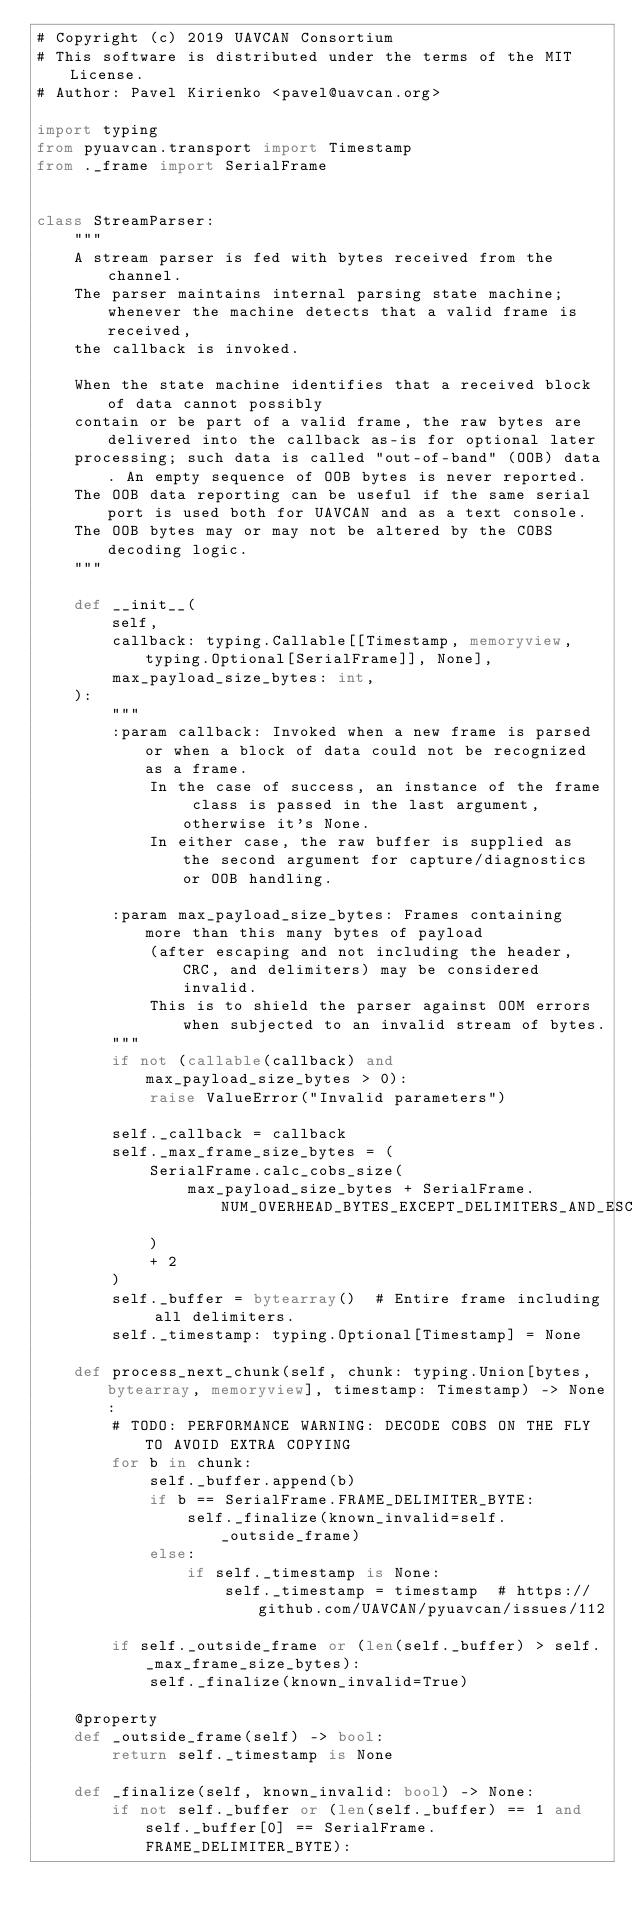Convert code to text. <code><loc_0><loc_0><loc_500><loc_500><_Python_># Copyright (c) 2019 UAVCAN Consortium
# This software is distributed under the terms of the MIT License.
# Author: Pavel Kirienko <pavel@uavcan.org>

import typing
from pyuavcan.transport import Timestamp
from ._frame import SerialFrame


class StreamParser:
    """
    A stream parser is fed with bytes received from the channel.
    The parser maintains internal parsing state machine; whenever the machine detects that a valid frame is received,
    the callback is invoked.

    When the state machine identifies that a received block of data cannot possibly
    contain or be part of a valid frame, the raw bytes are delivered into the callback as-is for optional later
    processing; such data is called "out-of-band" (OOB) data. An empty sequence of OOB bytes is never reported.
    The OOB data reporting can be useful if the same serial port is used both for UAVCAN and as a text console.
    The OOB bytes may or may not be altered by the COBS decoding logic.
    """

    def __init__(
        self,
        callback: typing.Callable[[Timestamp, memoryview, typing.Optional[SerialFrame]], None],
        max_payload_size_bytes: int,
    ):
        """
        :param callback: Invoked when a new frame is parsed or when a block of data could not be recognized as a frame.
            In the case of success, an instance of the frame class is passed in the last argument, otherwise it's None.
            In either case, the raw buffer is supplied as the second argument for capture/diagnostics or OOB handling.

        :param max_payload_size_bytes: Frames containing more than this many bytes of payload
            (after escaping and not including the header, CRC, and delimiters) may be considered invalid.
            This is to shield the parser against OOM errors when subjected to an invalid stream of bytes.
        """
        if not (callable(callback) and max_payload_size_bytes > 0):
            raise ValueError("Invalid parameters")

        self._callback = callback
        self._max_frame_size_bytes = (
            SerialFrame.calc_cobs_size(
                max_payload_size_bytes + SerialFrame.NUM_OVERHEAD_BYTES_EXCEPT_DELIMITERS_AND_ESCAPING
            )
            + 2
        )
        self._buffer = bytearray()  # Entire frame including all delimiters.
        self._timestamp: typing.Optional[Timestamp] = None

    def process_next_chunk(self, chunk: typing.Union[bytes, bytearray, memoryview], timestamp: Timestamp) -> None:
        # TODO: PERFORMANCE WARNING: DECODE COBS ON THE FLY TO AVOID EXTRA COPYING
        for b in chunk:
            self._buffer.append(b)
            if b == SerialFrame.FRAME_DELIMITER_BYTE:
                self._finalize(known_invalid=self._outside_frame)
            else:
                if self._timestamp is None:
                    self._timestamp = timestamp  # https://github.com/UAVCAN/pyuavcan/issues/112

        if self._outside_frame or (len(self._buffer) > self._max_frame_size_bytes):
            self._finalize(known_invalid=True)

    @property
    def _outside_frame(self) -> bool:
        return self._timestamp is None

    def _finalize(self, known_invalid: bool) -> None:
        if not self._buffer or (len(self._buffer) == 1 and self._buffer[0] == SerialFrame.FRAME_DELIMITER_BYTE):</code> 